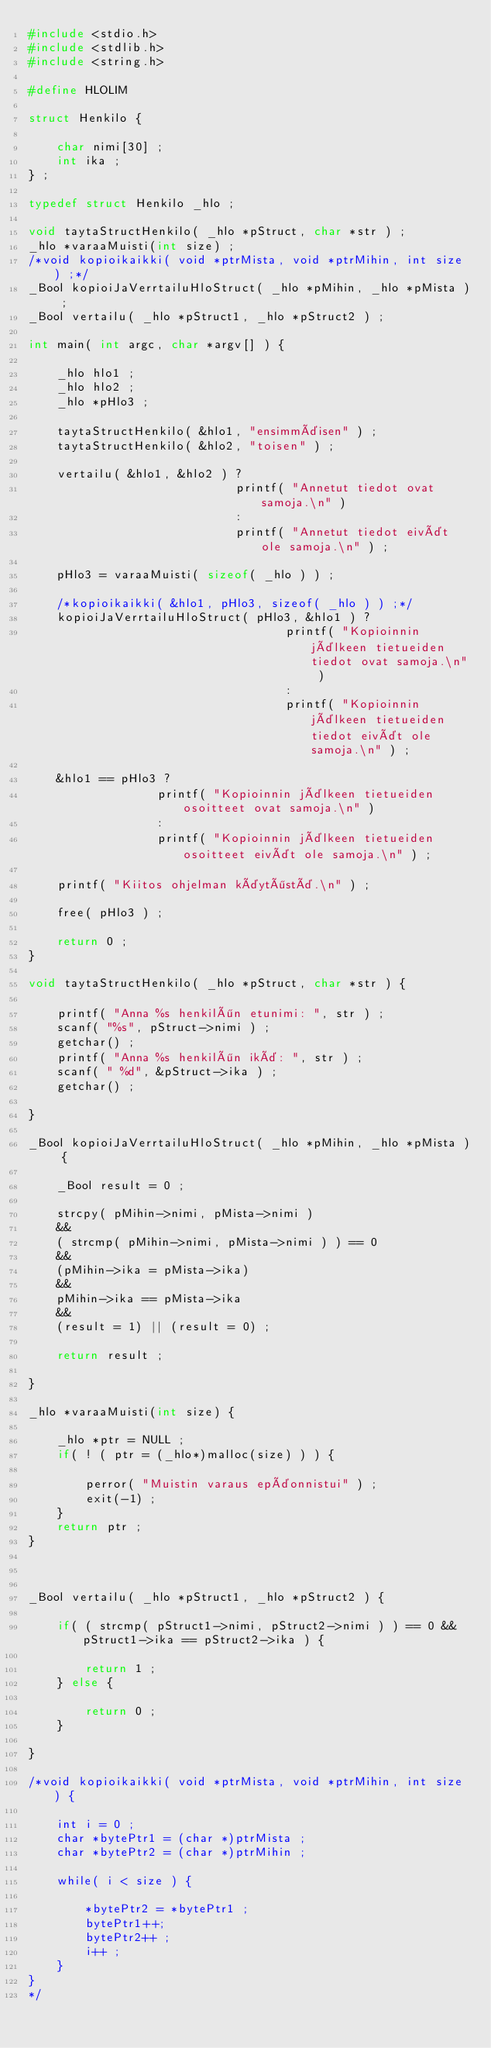Convert code to text. <code><loc_0><loc_0><loc_500><loc_500><_C_>#include <stdio.h>
#include <stdlib.h>
#include <string.h>

#define HLOLIM

struct Henkilo {

    char nimi[30] ;
    int ika ;
} ;

typedef struct Henkilo _hlo ;

void taytaStructHenkilo( _hlo *pStruct, char *str ) ;
_hlo *varaaMuisti(int size) ;
/*void kopioikaikki( void *ptrMista, void *ptrMihin, int size ) ;*/
_Bool kopioiJaVerrtailuHloStruct( _hlo *pMihin, _hlo *pMista ) ;
_Bool vertailu( _hlo *pStruct1, _hlo *pStruct2 ) ;

int main( int argc, char *argv[] ) {

    _hlo hlo1 ;
    _hlo hlo2 ;
    _hlo *pHlo3 ;

    taytaStructHenkilo( &hlo1, "ensimmäisen" ) ;
    taytaStructHenkilo( &hlo2, "toisen" ) ;

    vertailu( &hlo1, &hlo2 ) ?
                             printf( "Annetut tiedot ovat samoja.\n" )
                             :
                             printf( "Annetut tiedot eivät ole samoja.\n" ) ;

    pHlo3 = varaaMuisti( sizeof( _hlo ) ) ;

    /*kopioikaikki( &hlo1, pHlo3, sizeof( _hlo ) ) ;*/
    kopioiJaVerrtailuHloStruct( pHlo3, &hlo1 ) ?
                                    printf( "Kopioinnin jälkeen tietueiden tiedot ovat samoja.\n" )
                                    :
                                    printf( "Kopioinnin jälkeen tietueiden tiedot eivät ole samoja.\n" ) ;

    &hlo1 == pHlo3 ?
                  printf( "Kopioinnin jälkeen tietueiden osoitteet ovat samoja.\n" )
                  :
                  printf( "Kopioinnin jälkeen tietueiden osoitteet eivät ole samoja.\n" ) ;

    printf( "Kiitos ohjelman käytöstä.\n" ) ;

    free( pHlo3 ) ;

    return 0 ;
}

void taytaStructHenkilo( _hlo *pStruct, char *str ) {

    printf( "Anna %s henkilön etunimi: ", str ) ;
    scanf( "%s", pStruct->nimi ) ;
    getchar() ;
    printf( "Anna %s henkilön ikä: ", str ) ;
    scanf( " %d", &pStruct->ika ) ;
    getchar() ;

}

_Bool kopioiJaVerrtailuHloStruct( _hlo *pMihin, _hlo *pMista ) {

    _Bool result = 0 ;

    strcpy( pMihin->nimi, pMista->nimi )
    &&
    ( strcmp( pMihin->nimi, pMista->nimi ) ) == 0
    &&
    (pMihin->ika = pMista->ika)
    &&
    pMihin->ika == pMista->ika
    &&
    (result = 1) || (result = 0) ;

    return result ;

}

_hlo *varaaMuisti(int size) {

    _hlo *ptr = NULL ;
    if( ! ( ptr = (_hlo*)malloc(size) ) ) {

        perror( "Muistin varaus epäonnistui" ) ;
        exit(-1) ;
    }
    return ptr ;
}



_Bool vertailu( _hlo *pStruct1, _hlo *pStruct2 ) {

    if( ( strcmp( pStruct1->nimi, pStruct2->nimi ) ) == 0 && pStruct1->ika == pStruct2->ika ) {

        return 1 ;
    } else {

        return 0 ;
    }

}

/*void kopioikaikki( void *ptrMista, void *ptrMihin, int size ) {

    int i = 0 ;
    char *bytePtr1 = (char *)ptrMista ;
    char *bytePtr2 = (char *)ptrMihin ;

    while( i < size ) {

        *bytePtr2 = *bytePtr1 ;
        bytePtr1++;
        bytePtr2++ ;
        i++ ;
    }
}
*/
</code> 